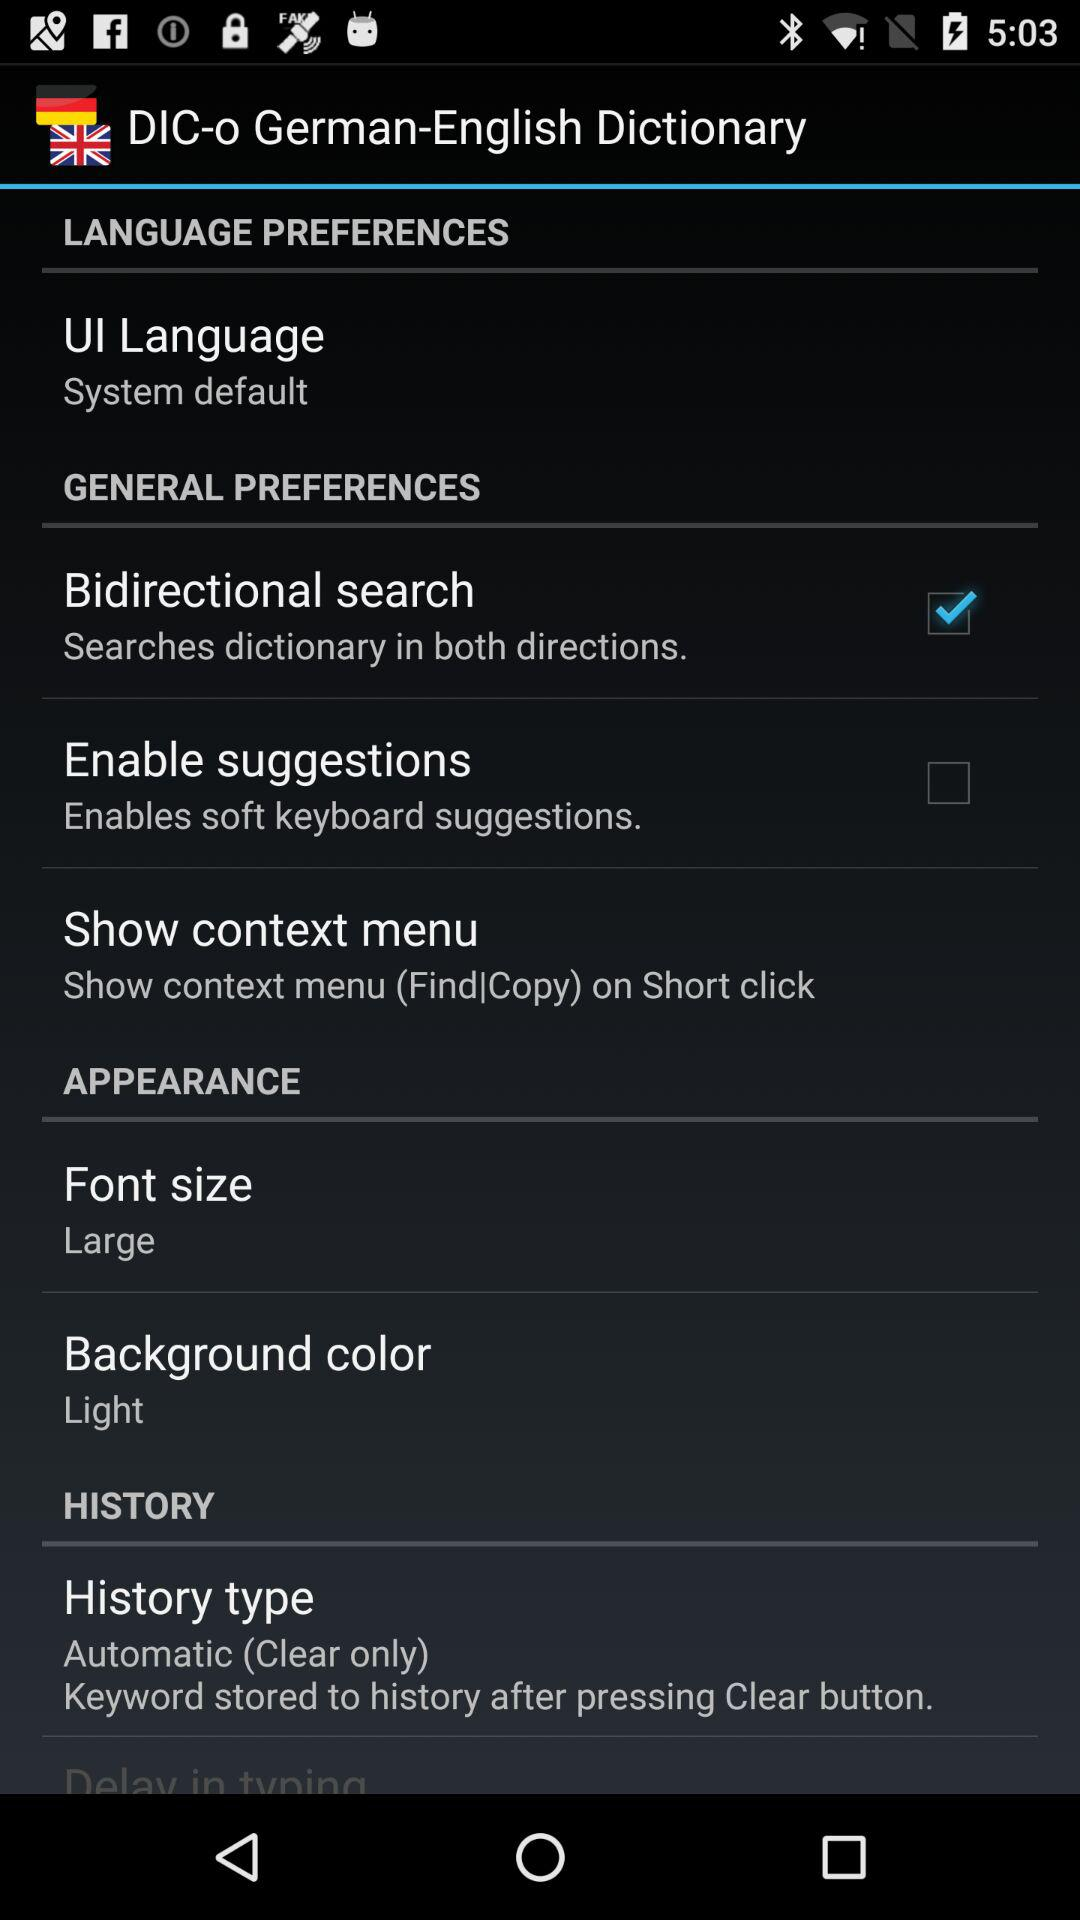What is the description of "History type"? The description of "History type" is "Keyword stored to history after pressing Clear button". 